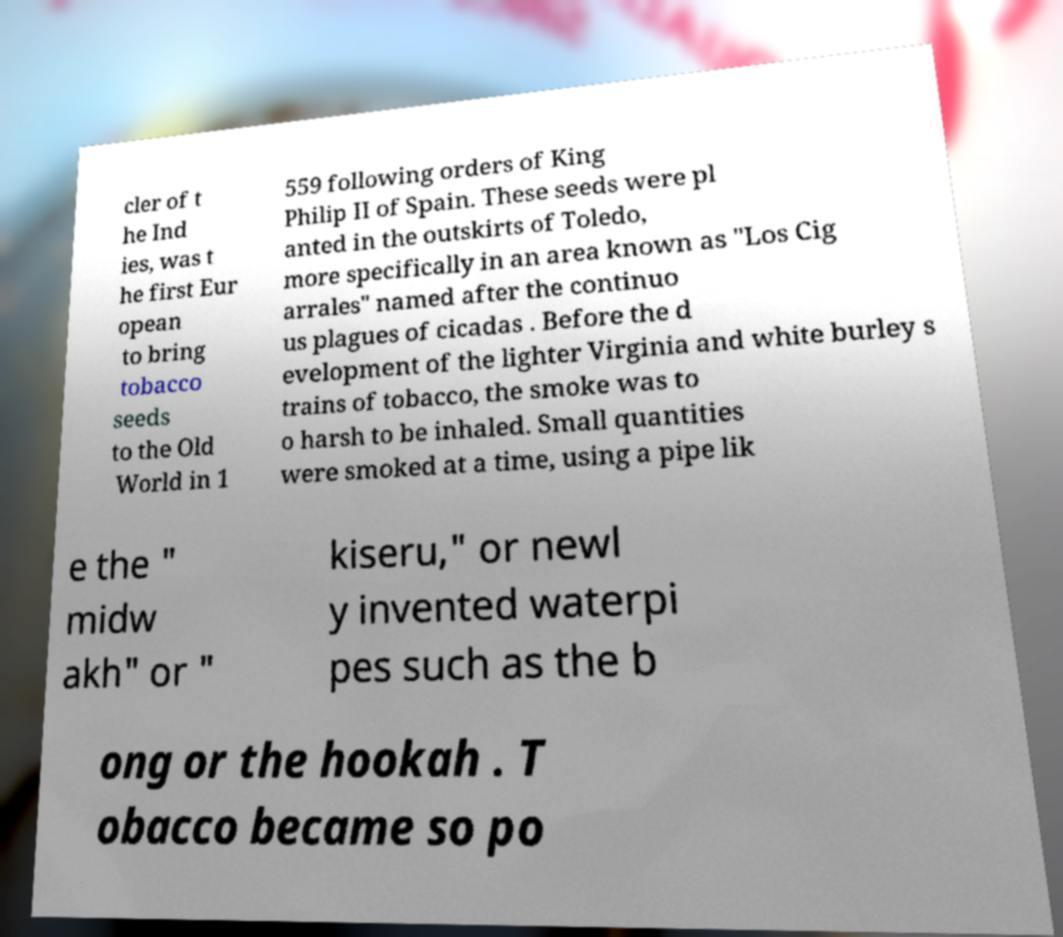Can you read and provide the text displayed in the image?This photo seems to have some interesting text. Can you extract and type it out for me? cler of t he Ind ies, was t he first Eur opean to bring tobacco seeds to the Old World in 1 559 following orders of King Philip II of Spain. These seeds were pl anted in the outskirts of Toledo, more specifically in an area known as "Los Cig arrales" named after the continuo us plagues of cicadas . Before the d evelopment of the lighter Virginia and white burley s trains of tobacco, the smoke was to o harsh to be inhaled. Small quantities were smoked at a time, using a pipe lik e the " midw akh" or " kiseru," or newl y invented waterpi pes such as the b ong or the hookah . T obacco became so po 